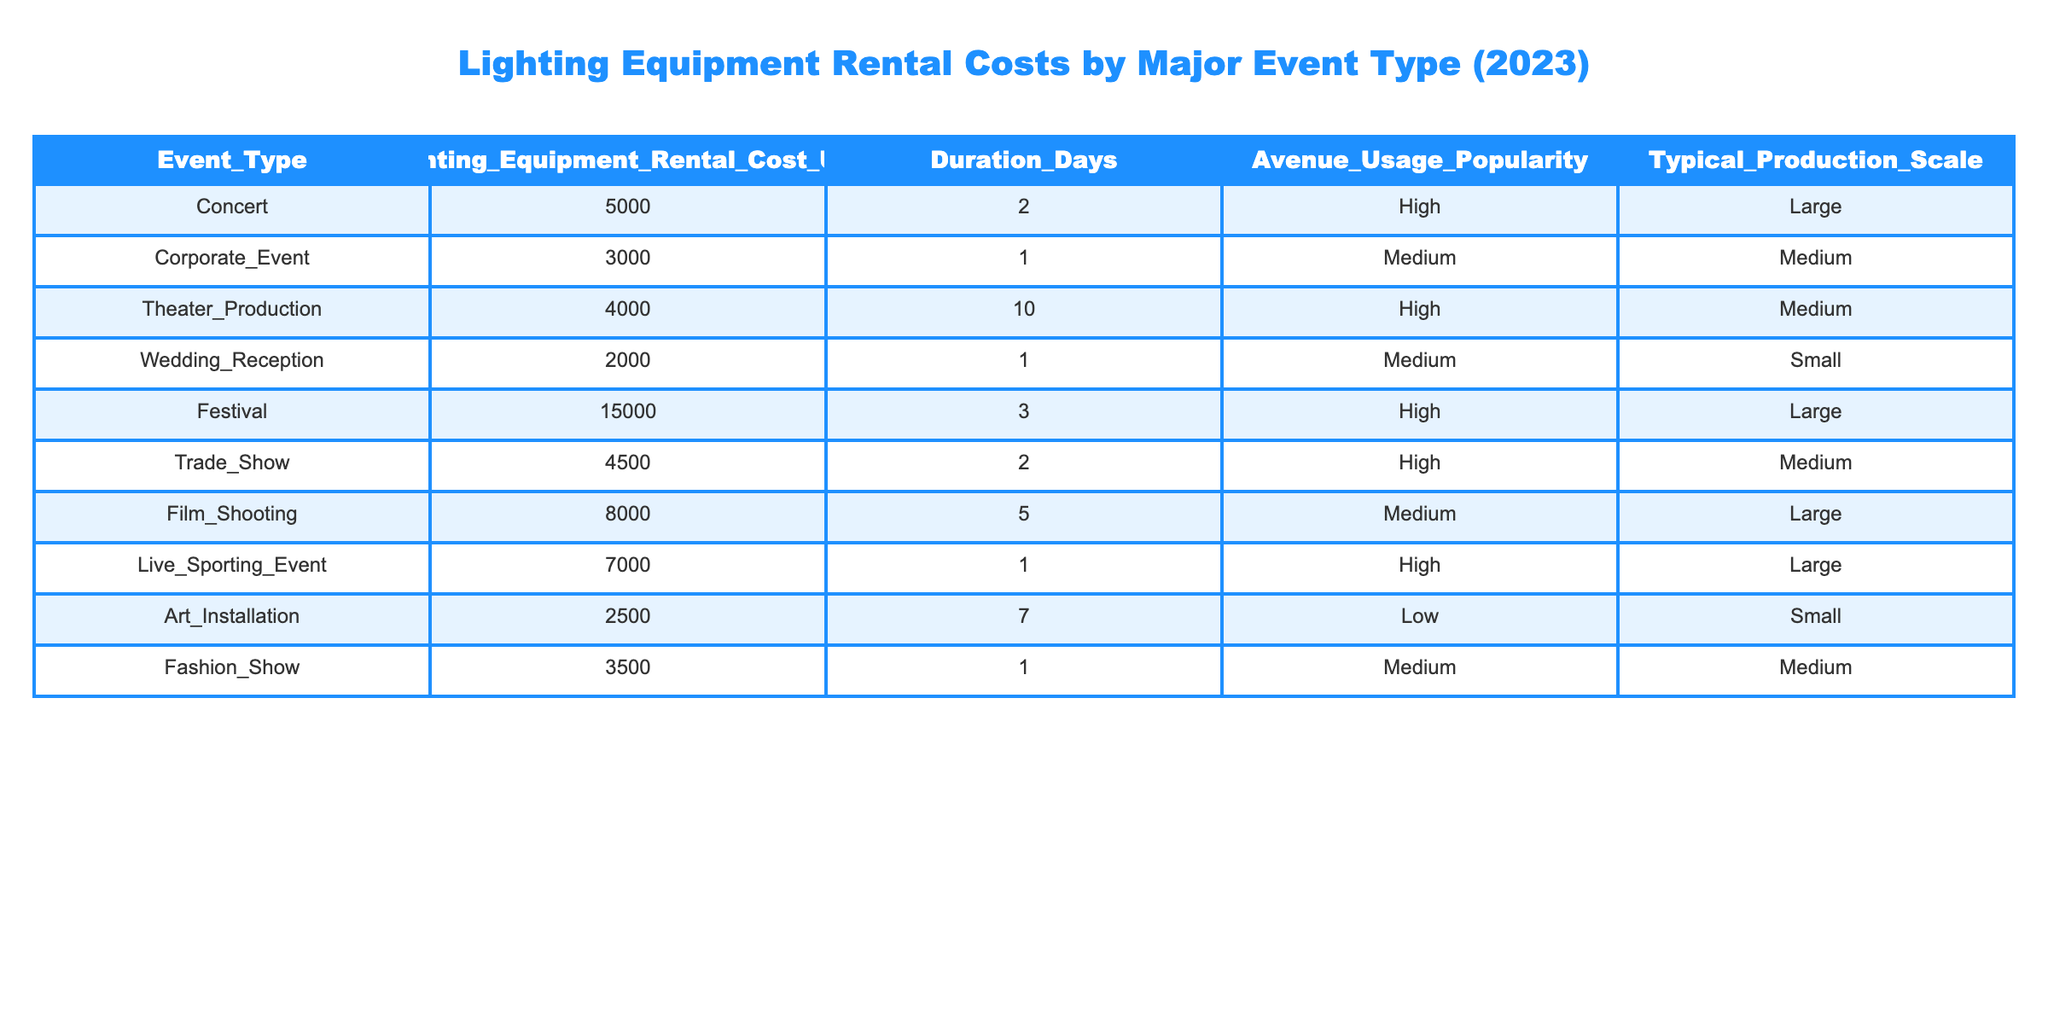What is the most expensive event type for lighting equipment rental? By reviewing the table, the "Festival" event type has the highest rental cost at $15,000.
Answer: Festival How much does it cost to rent lighting equipment for a wedding reception? The table shows that the rental cost for a Wedding Reception is $2,000.
Answer: $2,000 Which event type has the longest duration for lighting equipment rental? The "Theater Production" has the longest duration of 10 days listed in the table.
Answer: Theater Production What is the average lighting equipment rental cost across all events? To find the average, we sum the rental costs: (5000 + 3000 + 4000 + 2000 + 15000 + 4500 + 8000 + 7000 + 2500 + 3500) = 43500. There are 10 events, so the average is 43500 / 10 = 4350.
Answer: 4350 Is the lighting equipment rental cost for a Corporate Event higher than that for a Wedding Reception? The rental cost for a Corporate Event is $3,000, which is higher than the Wedding Reception cost of $2,000. Thus, the statement is true.
Answer: Yes How much more does it cost to rent lighting equipment for a Festival than for a Corporate Event? The cost for a Festival is $15,000 and for a Corporate Event is $3,000. The difference is $15,000 - $3,000 = $12,000.
Answer: $12,000 How many event types have a high popularity for avenue usage? By examining the table, there are 5 event types (Concert, Theater Production, Festival, Trade Show, and Live Sporting Event) that have a high popularity for avenue usage.
Answer: 5 If you combine the rental costs of a Corporate Event and a Fashion Show, how much would that be? The rental cost for a Corporate Event is $3,000, and for a Fashion Show, it is $3,500. Therefore, the total is $3,000 + $3,500 = $6,500.
Answer: $6,500 Which event types have a medium production scale? By looking at the table, the event types with medium production scale are Corporate Event, Theater Production, Film Shooting, Trade Show, and Fashion Show (totaling 5).
Answer: 5 Is there any event type where the lighting equipment rental cost is below $2,500? Based on the table, the lowest rental cost is $2,500 for an Art Installation, so there are no event types below this amount. Thus, the answer is false.
Answer: No 